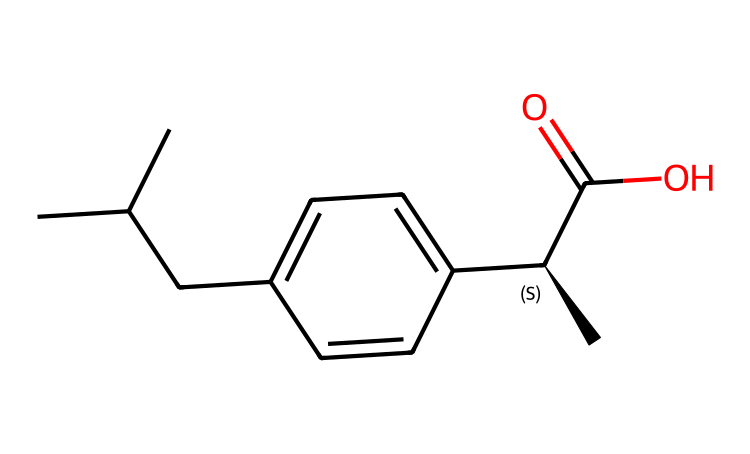What is the main functional group in ibuprofen? The chemical structure of ibuprofen contains a carboxylic acid functional group, which is identifiable by the presence of the -COOH group shown in the SMILES representation.
Answer: carboxylic acid How many carbon atoms are present in ibuprofen? By analyzing the SMILES representation, we count a total of 13 carbon atoms in the entire structure, including those in the alkyl chains and the aromatic ring.
Answer: 13 How many chiral centers does ibuprofen have? The structure of ibuprofen includes one chiral center, which is indicated by the notation [C@H] in the SMILES representation, showing that it has a specific configuration.
Answer: 1 What type of compound is ibuprofen? Ibuprofen is classified as a nonsteroidal anti-inflammatory drug (NSAID), which is indicated by its structure and functional groups that provide pain relief and anti-inflammatory properties.
Answer: NSAID What is the molecular weight of ibuprofen? The molecular weight can be derived from adding the atomic weights of all atoms in the structure, which results in a molecular weight of approximately 206.28 grams per mole.
Answer: 206.28 Which part of ibuprofen contributes to its analgesic effect? The effectiveness of ibuprofen as an analgesic is primarily due to the aromatic ring in its structure, which plays a crucial role in binding to pain receptors.
Answer: aromatic ring 